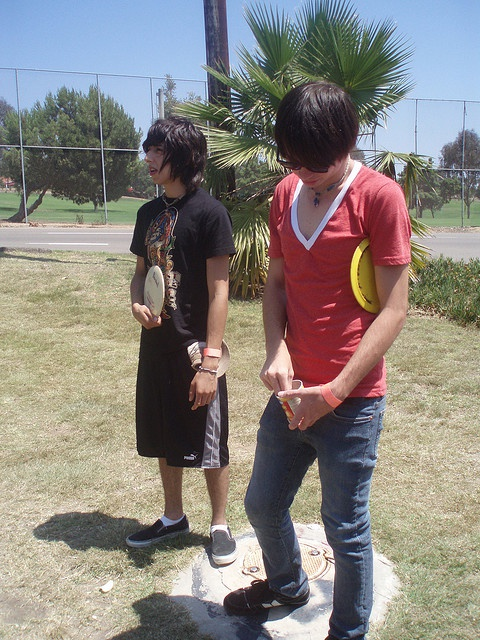Describe the objects in this image and their specific colors. I can see people in darkgray, black, maroon, and gray tones, people in darkgray, black, gray, and maroon tones, frisbee in darkgray, olive, and maroon tones, and cup in darkgray, brown, gray, and tan tones in this image. 